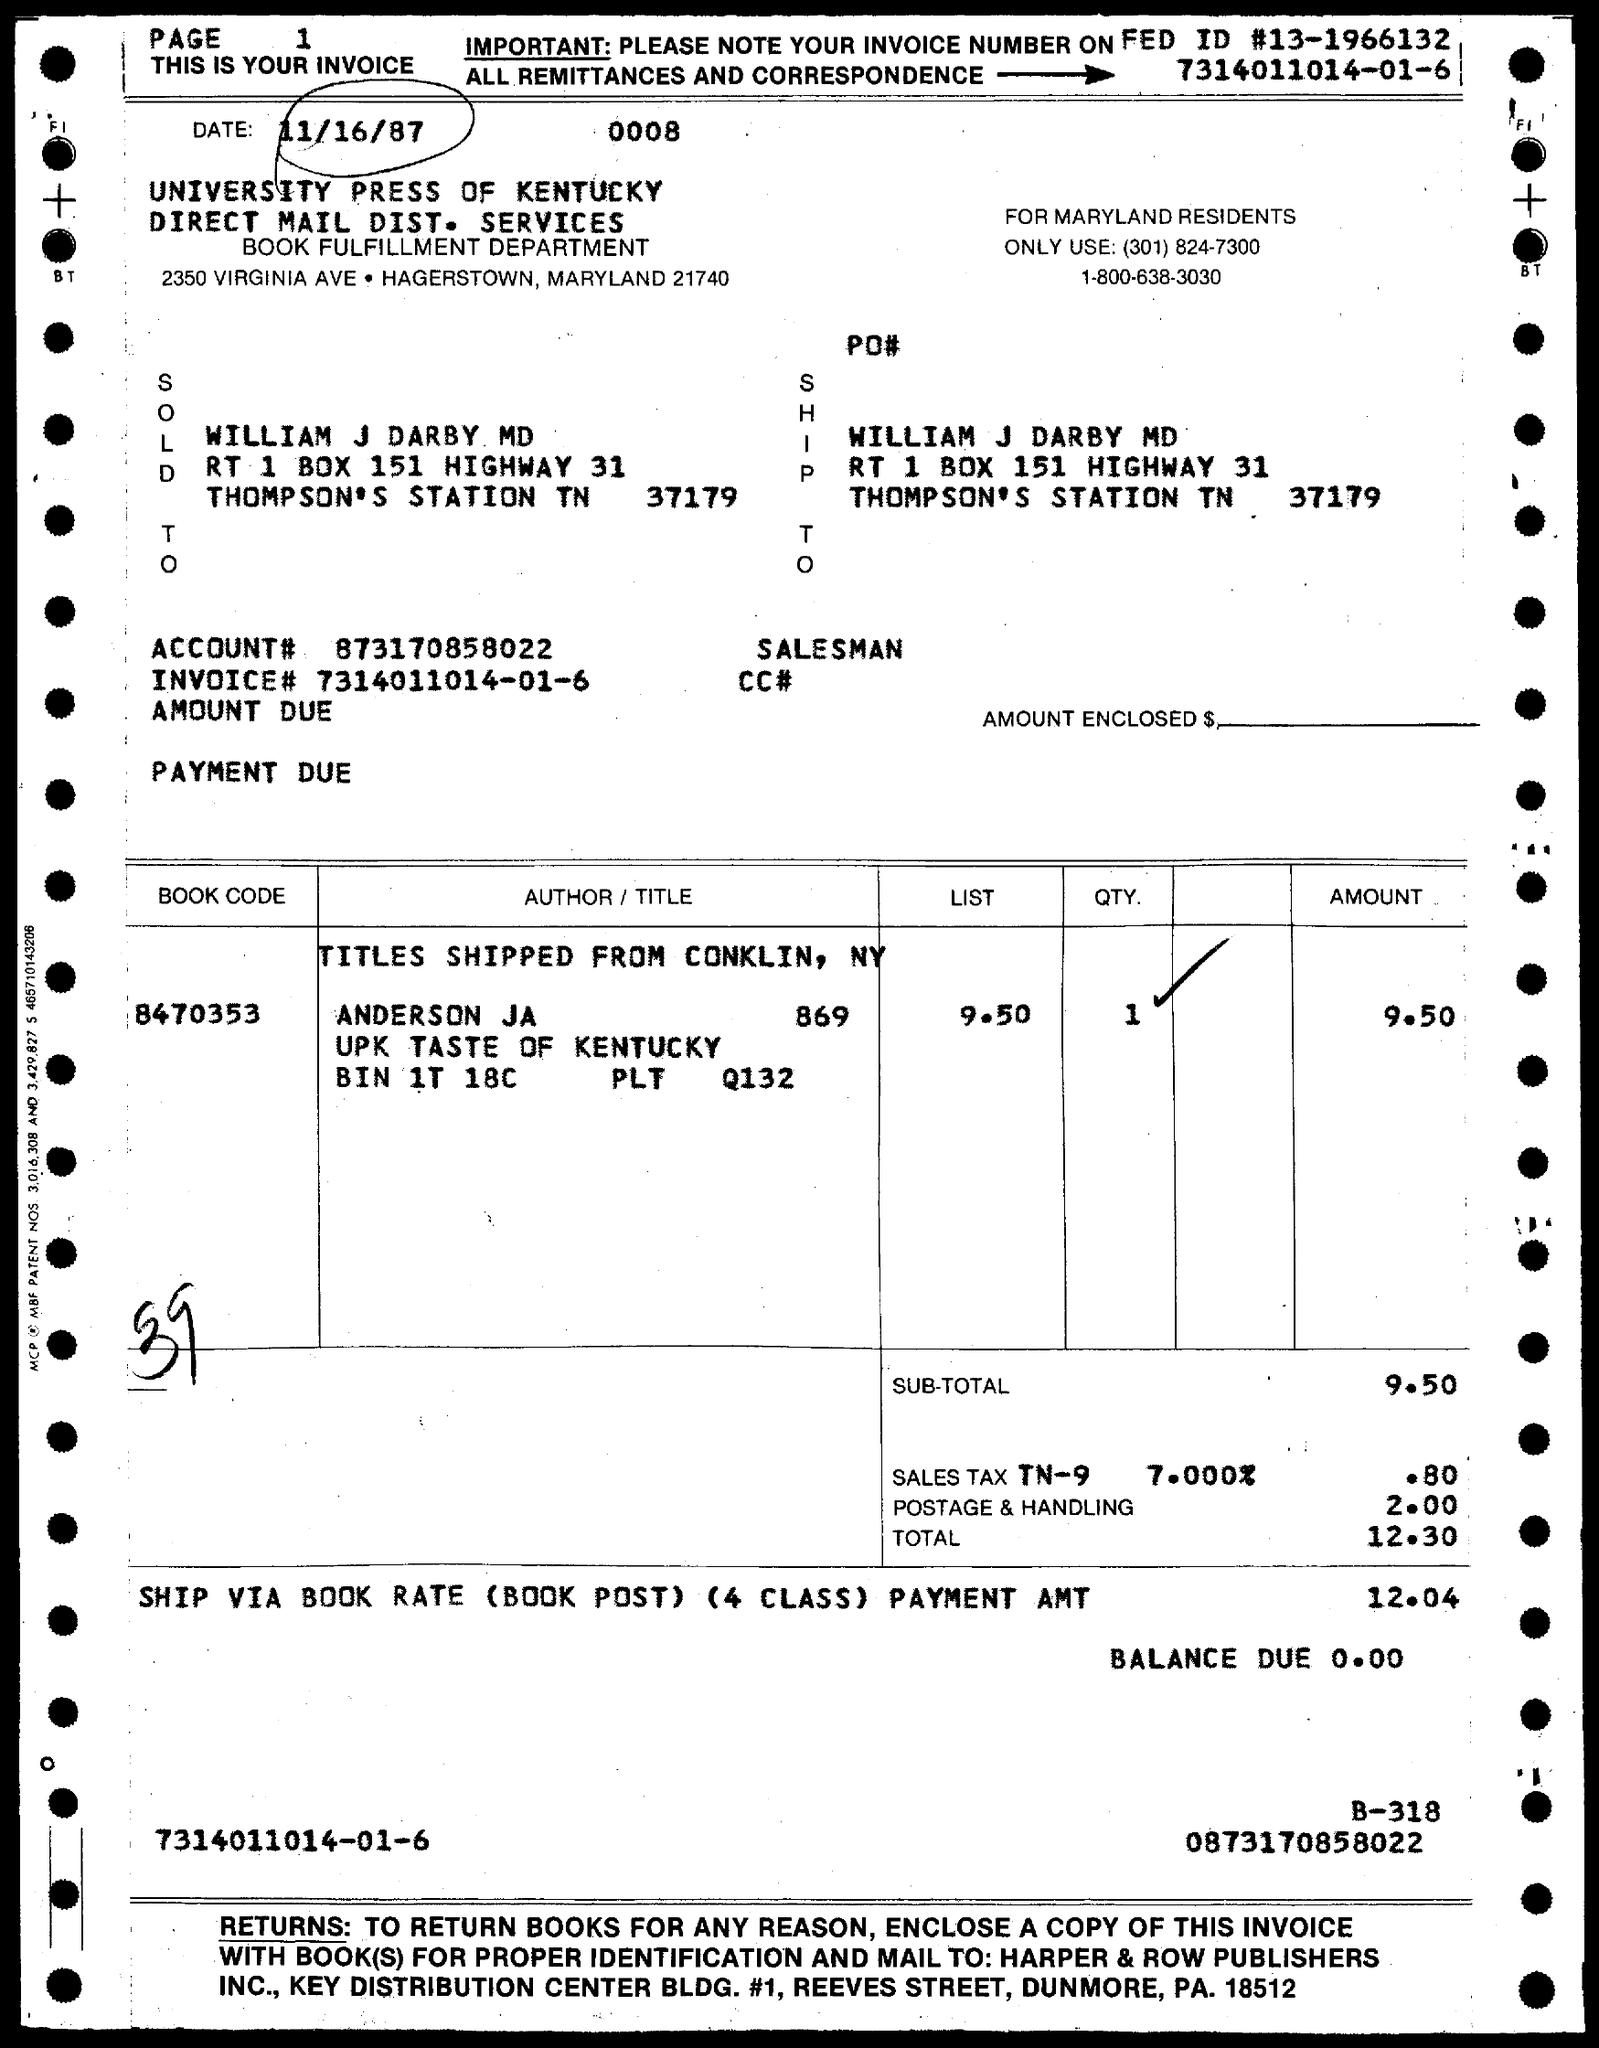What is the date?
Provide a short and direct response. 11/16/87. What is the book code?
Your answer should be very brief. 8470353. 